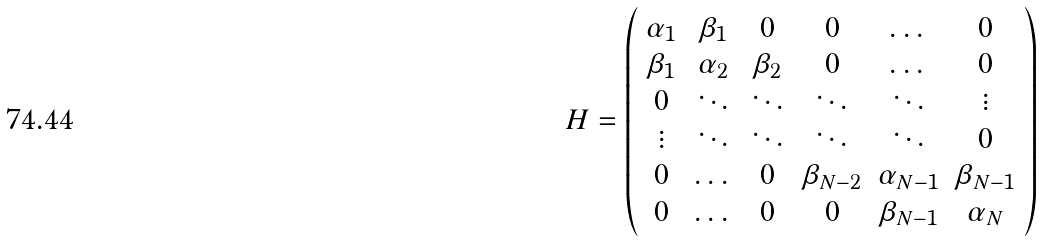<formula> <loc_0><loc_0><loc_500><loc_500>H = \left ( \begin{array} { c c c c c c } \alpha _ { 1 } & \beta _ { 1 } & 0 & 0 & \dots & 0 \\ \beta _ { 1 } & \alpha _ { 2 } & \beta _ { 2 } & 0 & \dots & 0 \\ 0 & \ddots & \ddots & \ddots & \ddots & \vdots \\ \vdots & \ddots & \ddots & \ddots & \ddots & 0 \\ 0 & \dots & 0 & \beta _ { N - 2 } & \alpha _ { N - 1 } & \beta _ { N - 1 } \\ 0 & \dots & 0 & 0 & \beta _ { N - 1 } & \alpha _ { N } \end{array} \right )</formula> 